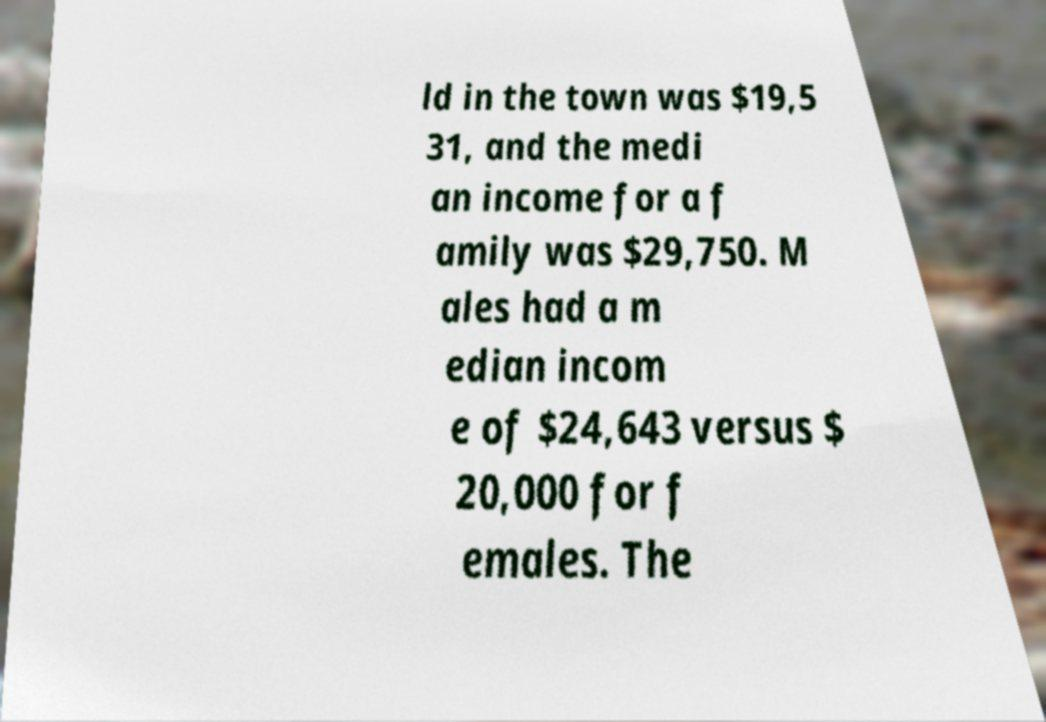Could you extract and type out the text from this image? ld in the town was $19,5 31, and the medi an income for a f amily was $29,750. M ales had a m edian incom e of $24,643 versus $ 20,000 for f emales. The 